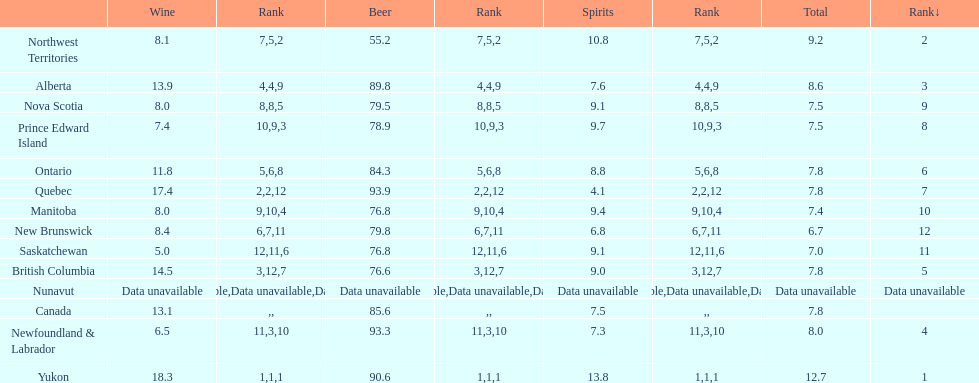Tell me province that drank more than 15 liters of wine. Yukon, Quebec. 